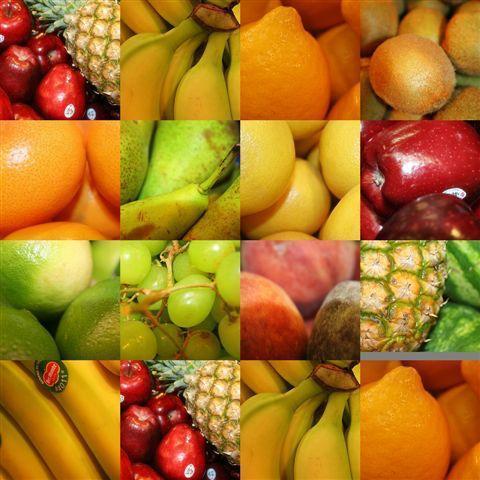How many pictures of bananas are there?
Give a very brief answer. 3. How many apples are there?
Give a very brief answer. 5. How many oranges are there?
Give a very brief answer. 4. How many bananas can be seen?
Give a very brief answer. 4. How many trains are visible?
Give a very brief answer. 0. 